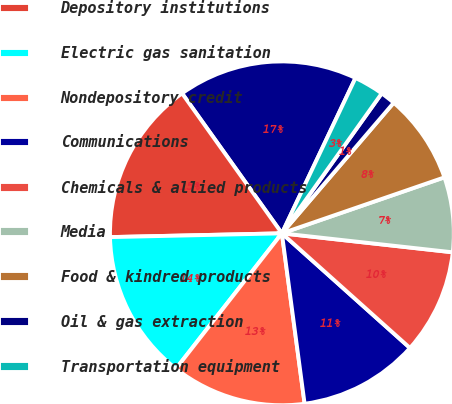Convert chart to OTSL. <chart><loc_0><loc_0><loc_500><loc_500><pie_chart><fcel>Insurance carriers<fcel>Depository institutions<fcel>Electric gas sanitation<fcel>Nondepository credit<fcel>Communications<fcel>Chemicals & allied products<fcel>Media<fcel>Food & kindred products<fcel>Oil & gas extraction<fcel>Transportation equipment<nl><fcel>16.9%<fcel>15.49%<fcel>14.08%<fcel>12.68%<fcel>11.27%<fcel>9.86%<fcel>7.04%<fcel>8.45%<fcel>1.41%<fcel>2.82%<nl></chart> 